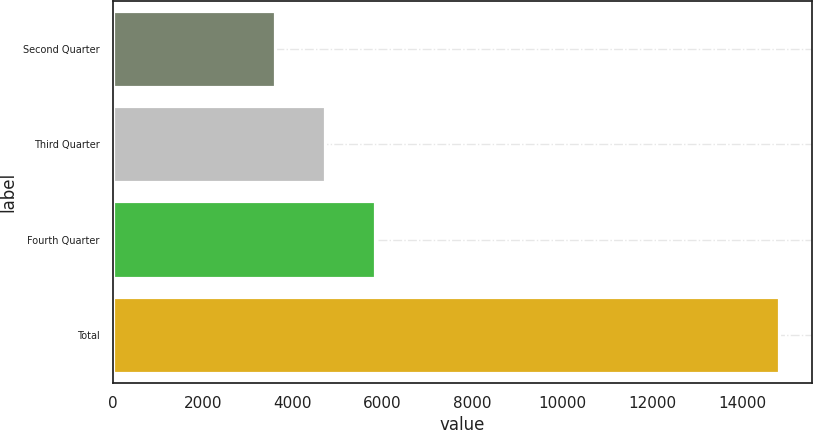<chart> <loc_0><loc_0><loc_500><loc_500><bar_chart><fcel>Second Quarter<fcel>Third Quarter<fcel>Fourth Quarter<fcel>Total<nl><fcel>3600<fcel>4720<fcel>5840<fcel>14800<nl></chart> 